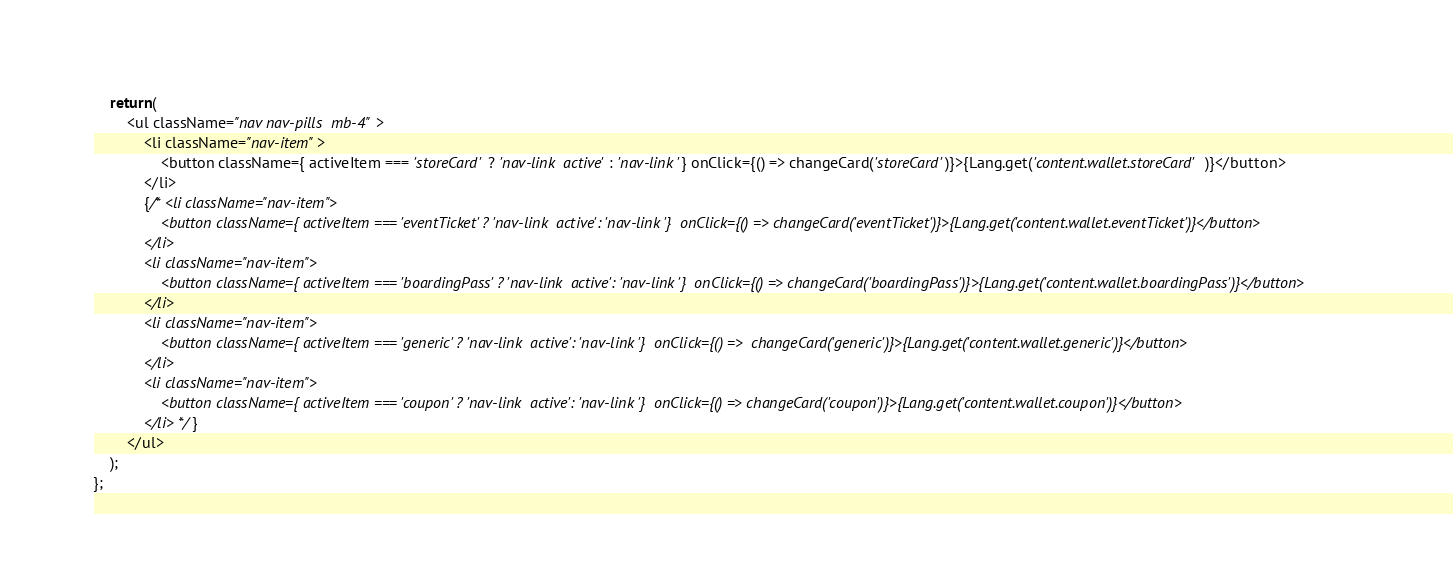Convert code to text. <code><loc_0><loc_0><loc_500><loc_500><_JavaScript_>
    return(
        <ul className="nav nav-pills  mb-4">
            <li className="nav-item">
                <button className={ activeItem === 'storeCard' ? 'nav-link  active': 'nav-link '} onClick={() => changeCard('storeCard')}>{Lang.get('content.wallet.storeCard')}</button>
            </li>
            {/* <li className="nav-item">
                <button className={ activeItem === 'eventTicket' ? 'nav-link  active': 'nav-link '}  onClick={() => changeCard('eventTicket')}>{Lang.get('content.wallet.eventTicket')}</button>
            </li>
            <li className="nav-item">
                <button className={ activeItem === 'boardingPass' ? 'nav-link  active': 'nav-link '}  onClick={() => changeCard('boardingPass')}>{Lang.get('content.wallet.boardingPass')}</button>
            </li>
            <li className="nav-item">
                <button className={ activeItem === 'generic' ? 'nav-link  active': 'nav-link '}  onClick={() =>  changeCard('generic')}>{Lang.get('content.wallet.generic')}</button>
            </li>
            <li className="nav-item">
                <button className={ activeItem === 'coupon' ? 'nav-link  active': 'nav-link '}  onClick={() => changeCard('coupon')}>{Lang.get('content.wallet.coupon')}</button>
            </li> */}
        </ul>
    );
};
</code> 